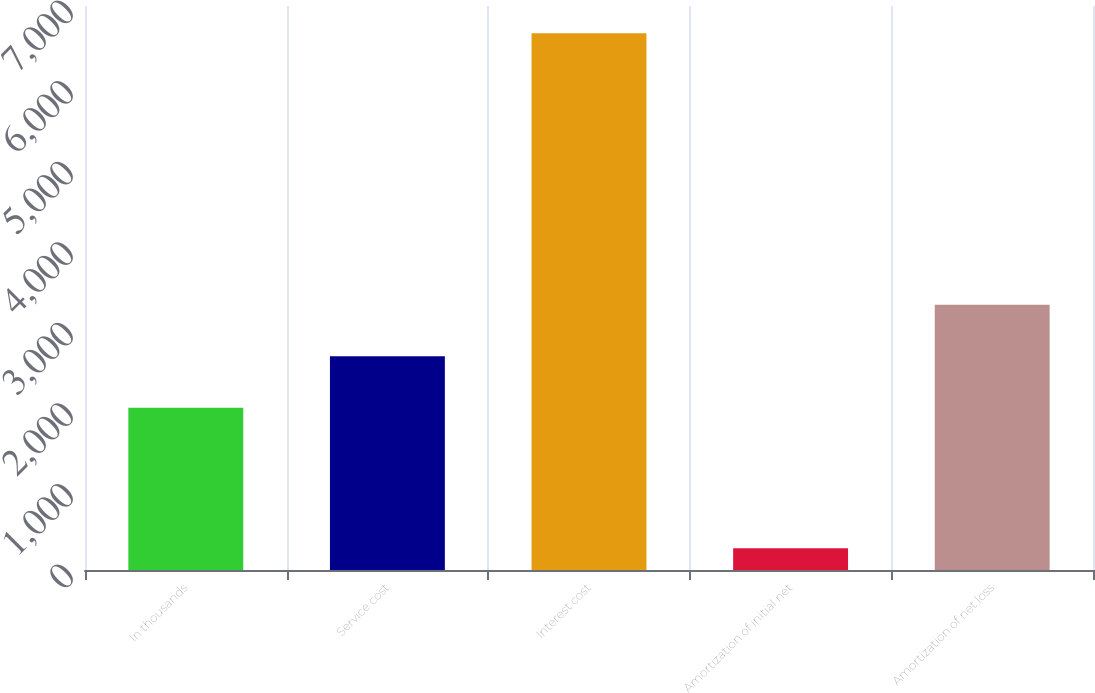Convert chart. <chart><loc_0><loc_0><loc_500><loc_500><bar_chart><fcel>In thousands<fcel>Service cost<fcel>Interest cost<fcel>Amortization of initial net<fcel>Amortization of net loss<nl><fcel>2013<fcel>2652.1<fcel>6661<fcel>270<fcel>3291.2<nl></chart> 